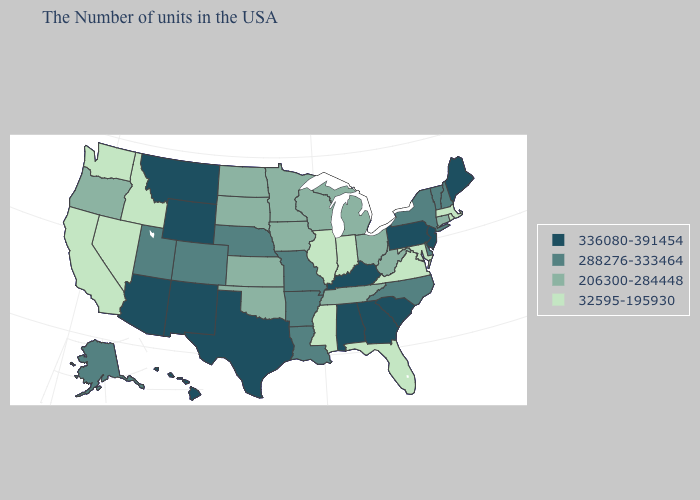What is the value of Georgia?
Keep it brief. 336080-391454. What is the lowest value in the USA?
Give a very brief answer. 32595-195930. Which states have the lowest value in the MidWest?
Keep it brief. Indiana, Illinois. What is the lowest value in the USA?
Give a very brief answer. 32595-195930. Does Indiana have the lowest value in the USA?
Answer briefly. Yes. What is the lowest value in states that border Missouri?
Short answer required. 32595-195930. Name the states that have a value in the range 288276-333464?
Keep it brief. New Hampshire, Vermont, New York, Delaware, North Carolina, Louisiana, Missouri, Arkansas, Nebraska, Colorado, Utah, Alaska. What is the highest value in the USA?
Write a very short answer. 336080-391454. Name the states that have a value in the range 288276-333464?
Answer briefly. New Hampshire, Vermont, New York, Delaware, North Carolina, Louisiana, Missouri, Arkansas, Nebraska, Colorado, Utah, Alaska. What is the value of West Virginia?
Short answer required. 206300-284448. Among the states that border Tennessee , which have the highest value?
Give a very brief answer. Georgia, Kentucky, Alabama. Name the states that have a value in the range 32595-195930?
Give a very brief answer. Massachusetts, Rhode Island, Maryland, Virginia, Florida, Indiana, Illinois, Mississippi, Idaho, Nevada, California, Washington. Name the states that have a value in the range 288276-333464?
Concise answer only. New Hampshire, Vermont, New York, Delaware, North Carolina, Louisiana, Missouri, Arkansas, Nebraska, Colorado, Utah, Alaska. Does Arkansas have the highest value in the USA?
Concise answer only. No. How many symbols are there in the legend?
Write a very short answer. 4. 